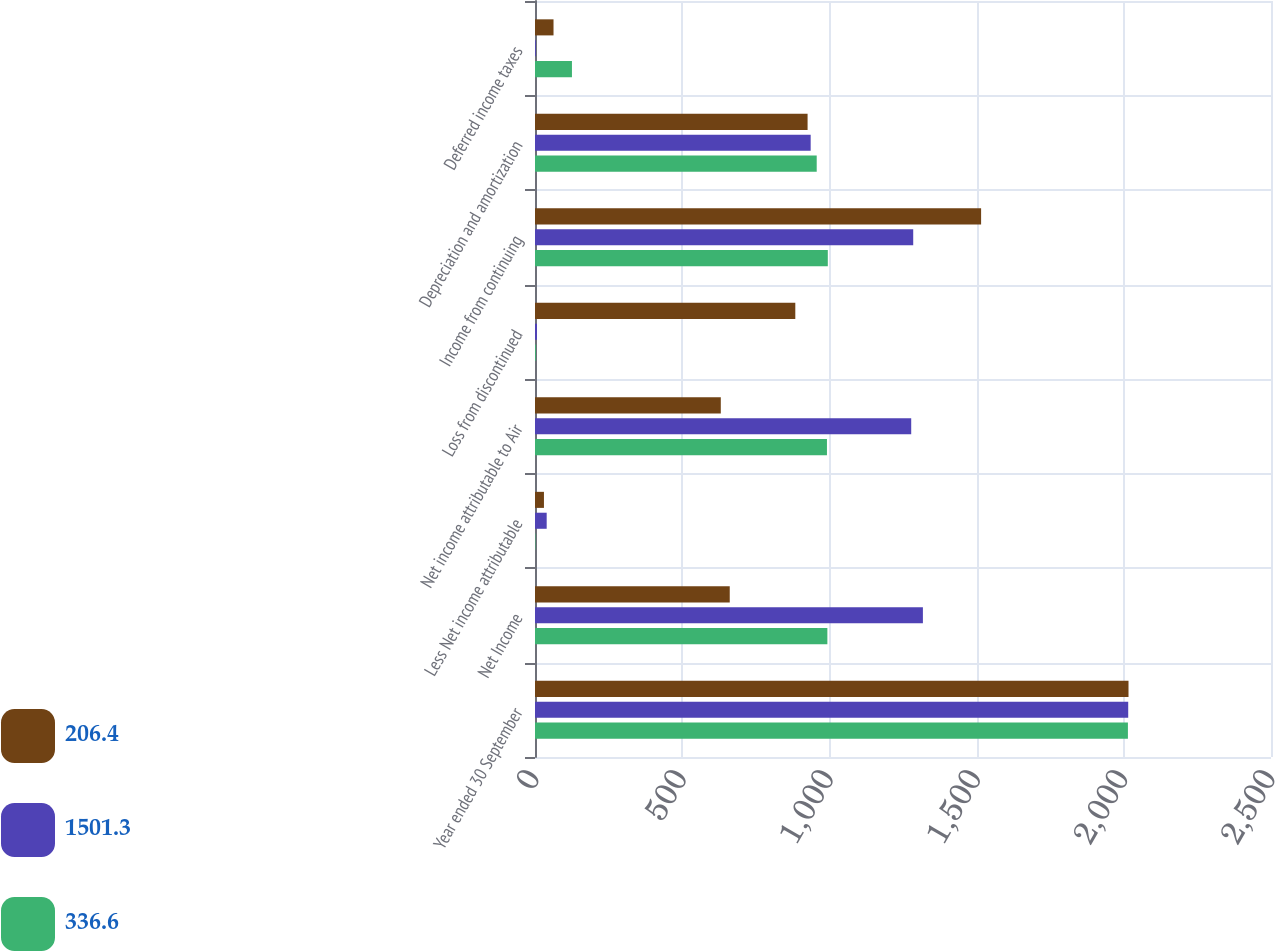Convert chart to OTSL. <chart><loc_0><loc_0><loc_500><loc_500><stacked_bar_chart><ecel><fcel>Year ended 30 September<fcel>Net Income<fcel>Less Net income attributable<fcel>Net income attributable to Air<fcel>Loss from discontinued<fcel>Income from continuing<fcel>Depreciation and amortization<fcel>Deferred income taxes<nl><fcel>206.4<fcel>2016<fcel>661.5<fcel>30.4<fcel>631.1<fcel>884.2<fcel>1515.3<fcel>925.9<fcel>62.9<nl><fcel>1501.3<fcel>2015<fcel>1317.6<fcel>39.7<fcel>1277.9<fcel>6.8<fcel>1284.7<fcel>936.4<fcel>2.9<nl><fcel>336.6<fcel>2014<fcel>993.1<fcel>1.4<fcel>991.7<fcel>2.9<fcel>994.6<fcel>956.9<fcel>125.5<nl></chart> 